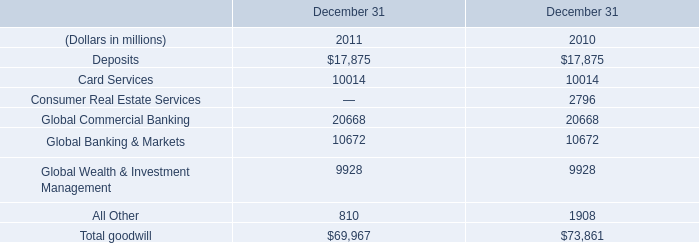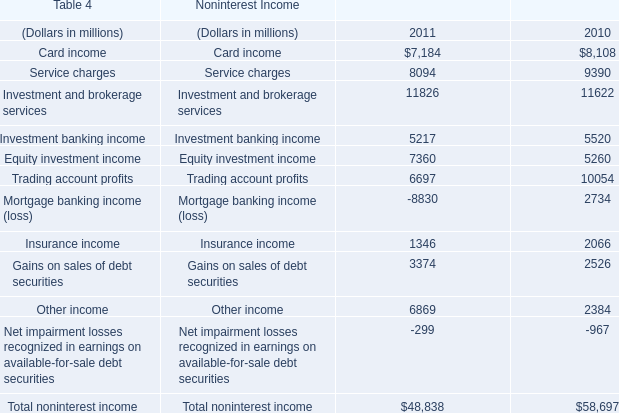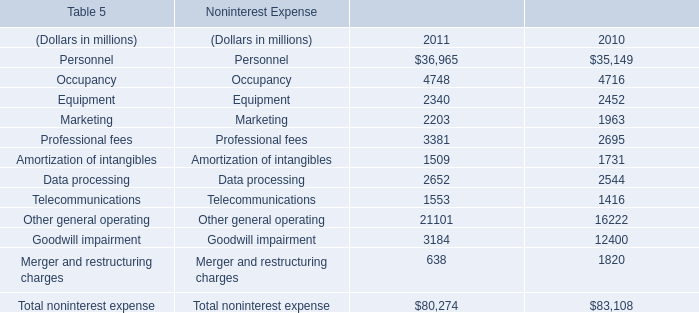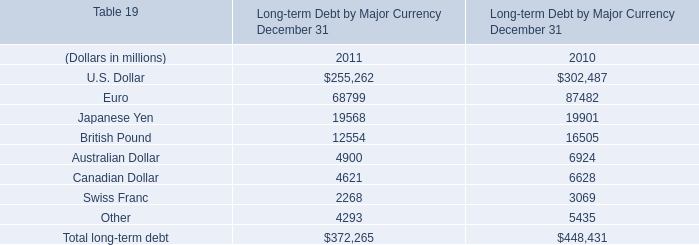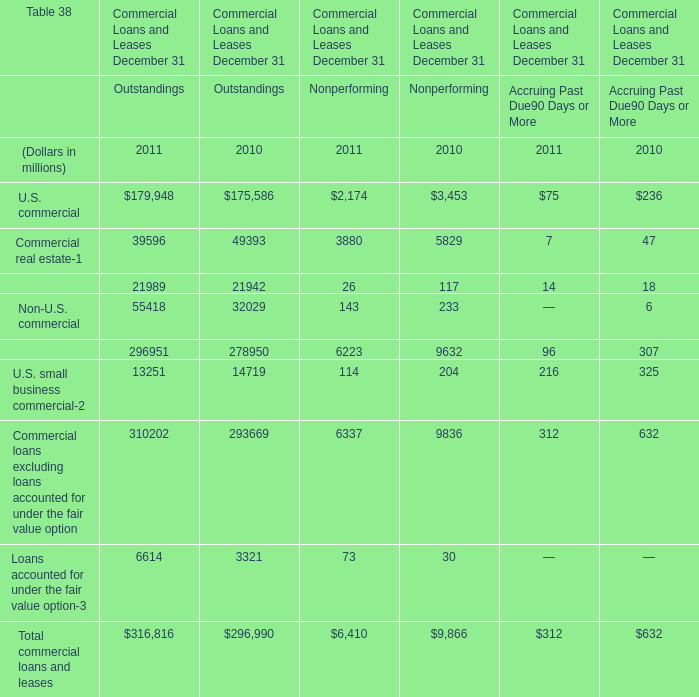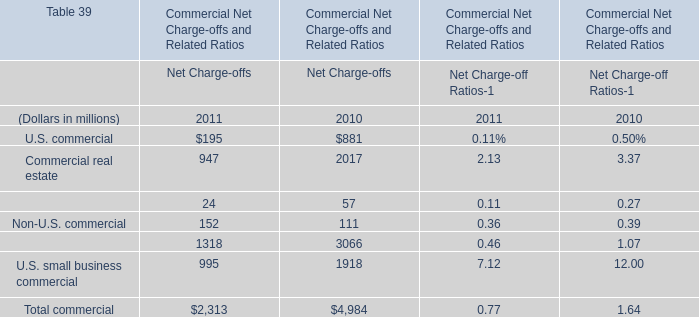What's the growth rate of Non-U.S. commercial in terms of Net Charge-offs in 2011? 
Computations: ((152 - 111) / 111)
Answer: 0.36937. 